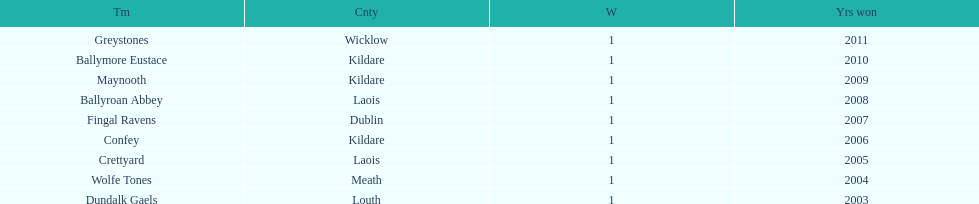Ballymore eustace is from the same county as what team that won in 2009? Maynooth. 